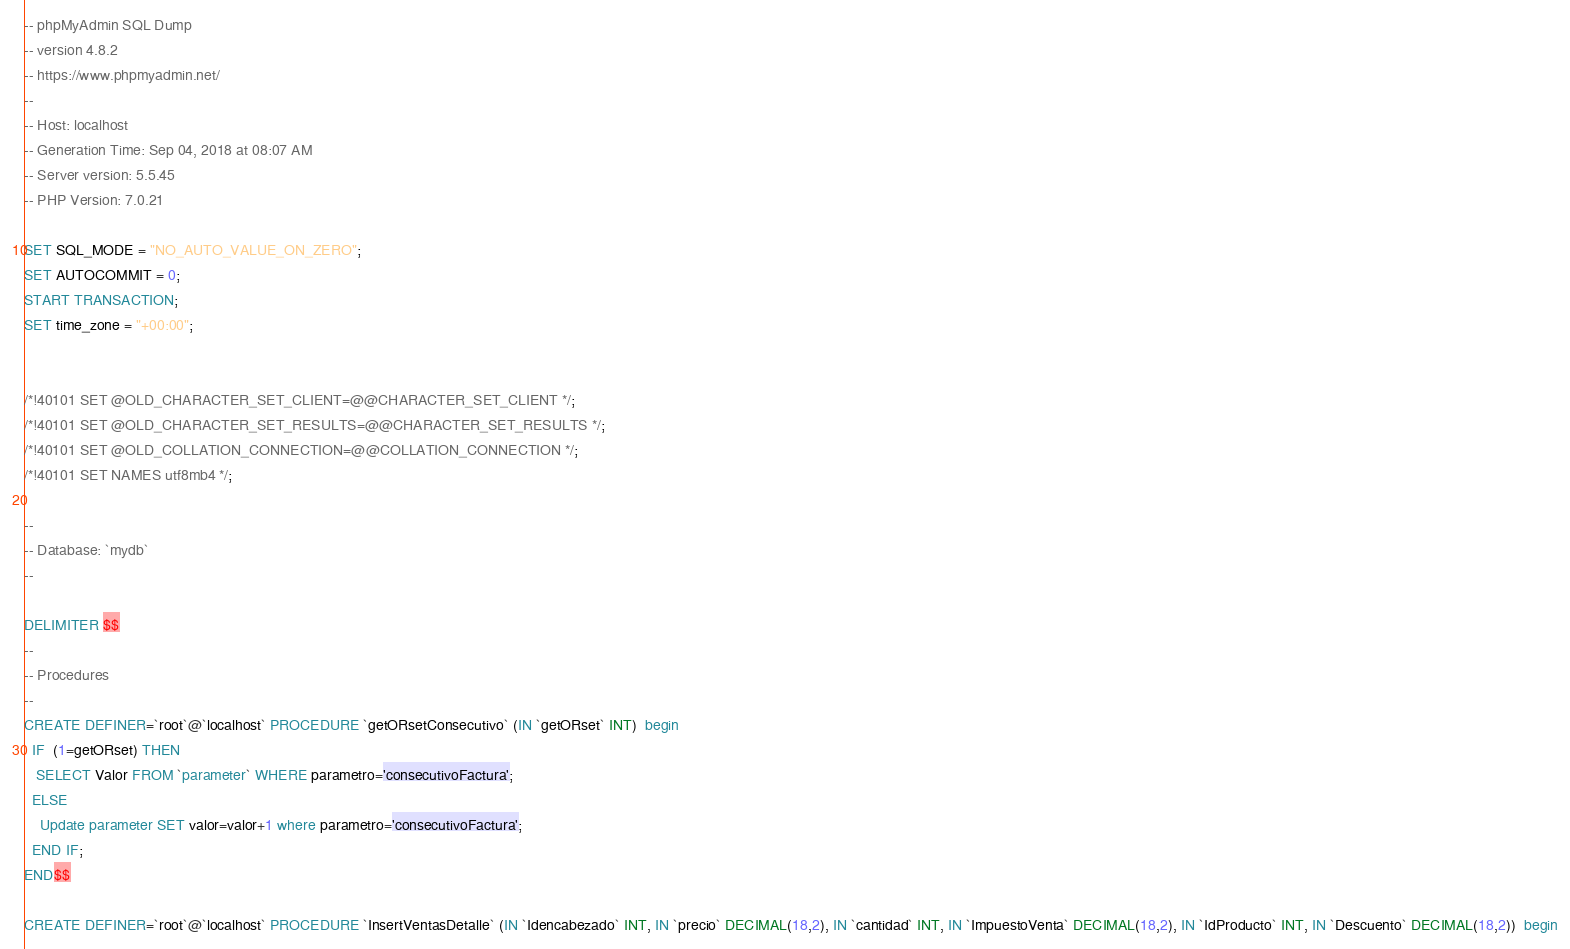<code> <loc_0><loc_0><loc_500><loc_500><_SQL_>-- phpMyAdmin SQL Dump
-- version 4.8.2
-- https://www.phpmyadmin.net/
--
-- Host: localhost
-- Generation Time: Sep 04, 2018 at 08:07 AM
-- Server version: 5.5.45
-- PHP Version: 7.0.21

SET SQL_MODE = "NO_AUTO_VALUE_ON_ZERO";
SET AUTOCOMMIT = 0;
START TRANSACTION;
SET time_zone = "+00:00";


/*!40101 SET @OLD_CHARACTER_SET_CLIENT=@@CHARACTER_SET_CLIENT */;
/*!40101 SET @OLD_CHARACTER_SET_RESULTS=@@CHARACTER_SET_RESULTS */;
/*!40101 SET @OLD_COLLATION_CONNECTION=@@COLLATION_CONNECTION */;
/*!40101 SET NAMES utf8mb4 */;

--
-- Database: `mydb`
--

DELIMITER $$
--
-- Procedures
--
CREATE DEFINER=`root`@`localhost` PROCEDURE `getORsetConsecutivo` (IN `getORset` INT)  begin
  IF  (1=getORset) THEN
   SELECT Valor FROM `parameter` WHERE parametro='consecutivoFactura';
  ELSE
    Update parameter SET valor=valor+1 where parametro='consecutivoFactura';
  END IF;
END$$

CREATE DEFINER=`root`@`localhost` PROCEDURE `InsertVentasDetalle` (IN `Idencabezado` INT, IN `precio` DECIMAL(18,2), IN `cantidad` INT, IN `ImpuestoVenta` DECIMAL(18,2), IN `IdProducto` INT, IN `Descuento` DECIMAL(18,2))  begin</code> 